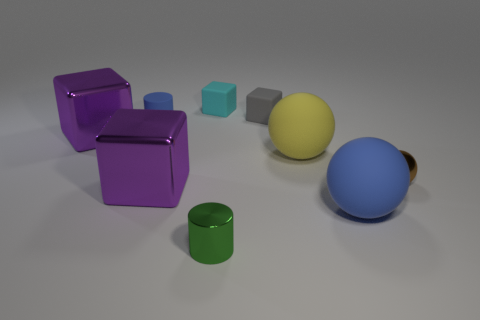Subtract all blue matte spheres. How many spheres are left? 2 Subtract 1 spheres. How many spheres are left? 2 Subtract all green cylinders. How many cylinders are left? 1 Subtract 0 cyan cylinders. How many objects are left? 9 Subtract all cubes. How many objects are left? 5 Subtract all green balls. Subtract all red cubes. How many balls are left? 3 Subtract all gray spheres. How many cyan cylinders are left? 0 Subtract all big yellow rubber balls. Subtract all small metallic balls. How many objects are left? 7 Add 2 tiny metallic cylinders. How many tiny metallic cylinders are left? 3 Add 2 big metallic cylinders. How many big metallic cylinders exist? 2 